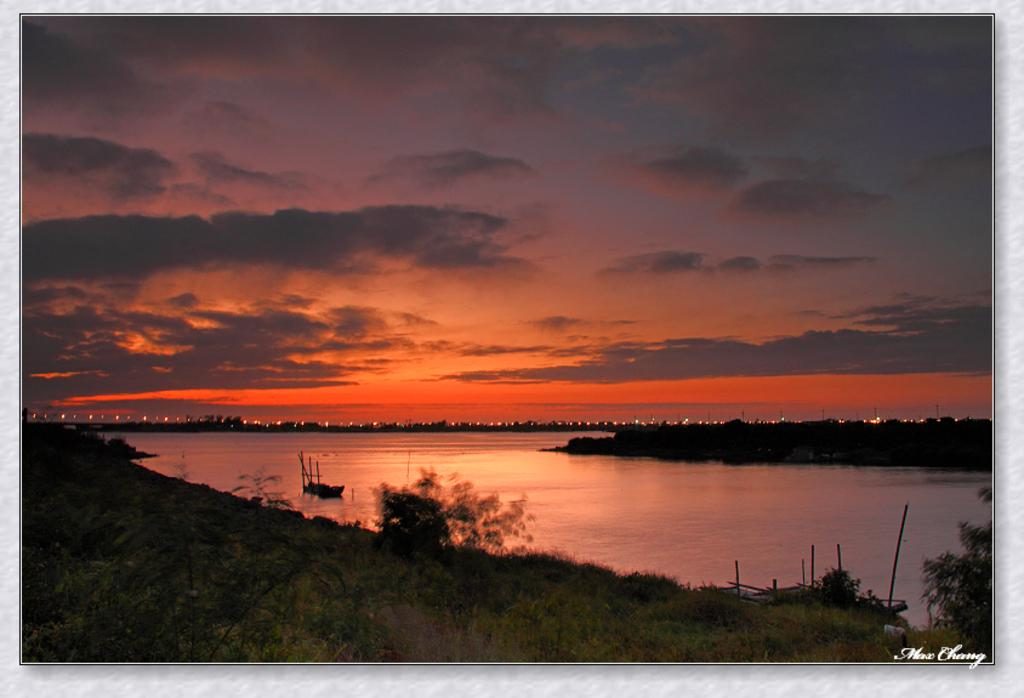What type of vegetation can be seen in the image? There are trees in the image. What is located on the water in the image? There is a boat on the water in the image. What can be seen illuminating the scene in the image? There are lights visible in the image. What part of the natural environment is visible in the image? The sky is visible in the image. What type of territory is being claimed by the rod in the image? There is no rod present in the image, so no territory is being claimed. What type of request is being made by the lights in the image? The lights in the image are not making any requests; they are simply illuminating the scene. 